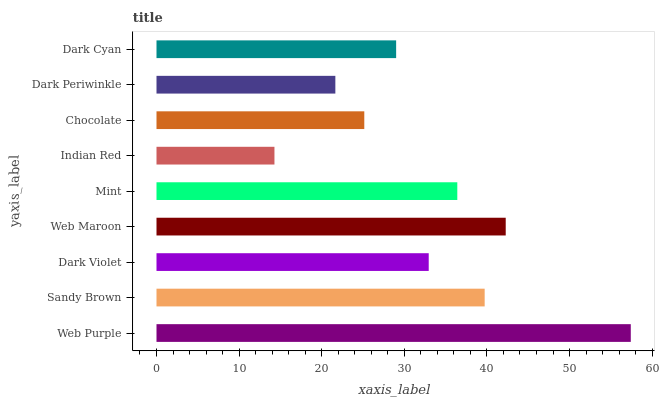Is Indian Red the minimum?
Answer yes or no. Yes. Is Web Purple the maximum?
Answer yes or no. Yes. Is Sandy Brown the minimum?
Answer yes or no. No. Is Sandy Brown the maximum?
Answer yes or no. No. Is Web Purple greater than Sandy Brown?
Answer yes or no. Yes. Is Sandy Brown less than Web Purple?
Answer yes or no. Yes. Is Sandy Brown greater than Web Purple?
Answer yes or no. No. Is Web Purple less than Sandy Brown?
Answer yes or no. No. Is Dark Violet the high median?
Answer yes or no. Yes. Is Dark Violet the low median?
Answer yes or no. Yes. Is Web Maroon the high median?
Answer yes or no. No. Is Web Maroon the low median?
Answer yes or no. No. 